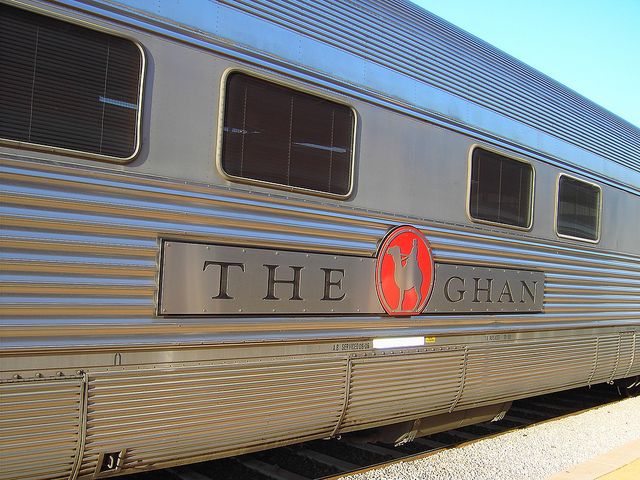Identify the text contained in this image. THE GHAN 